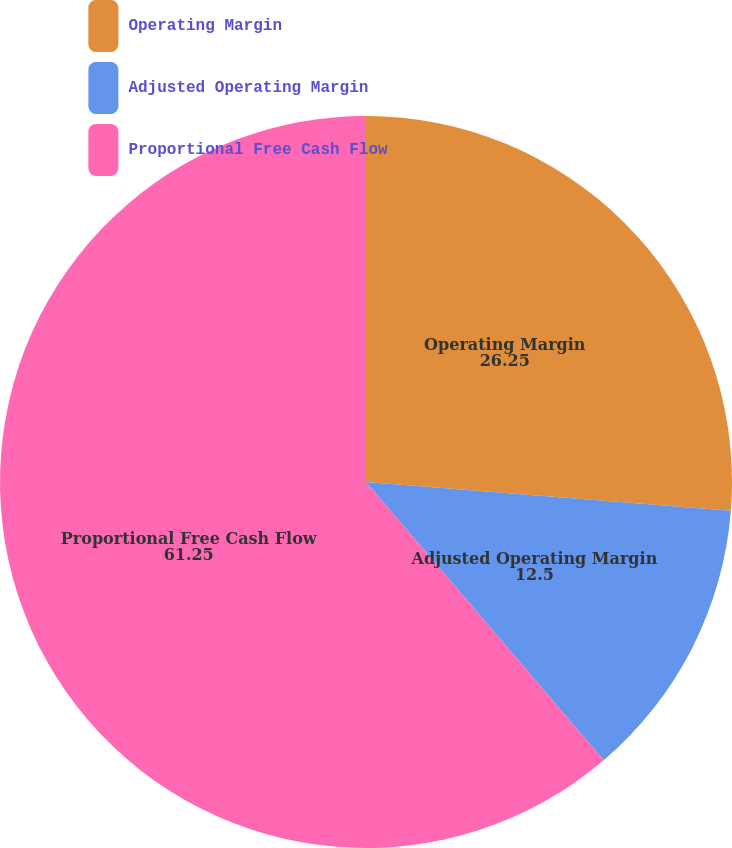Convert chart to OTSL. <chart><loc_0><loc_0><loc_500><loc_500><pie_chart><fcel>Operating Margin<fcel>Adjusted Operating Margin<fcel>Proportional Free Cash Flow<nl><fcel>26.25%<fcel>12.5%<fcel>61.25%<nl></chart> 